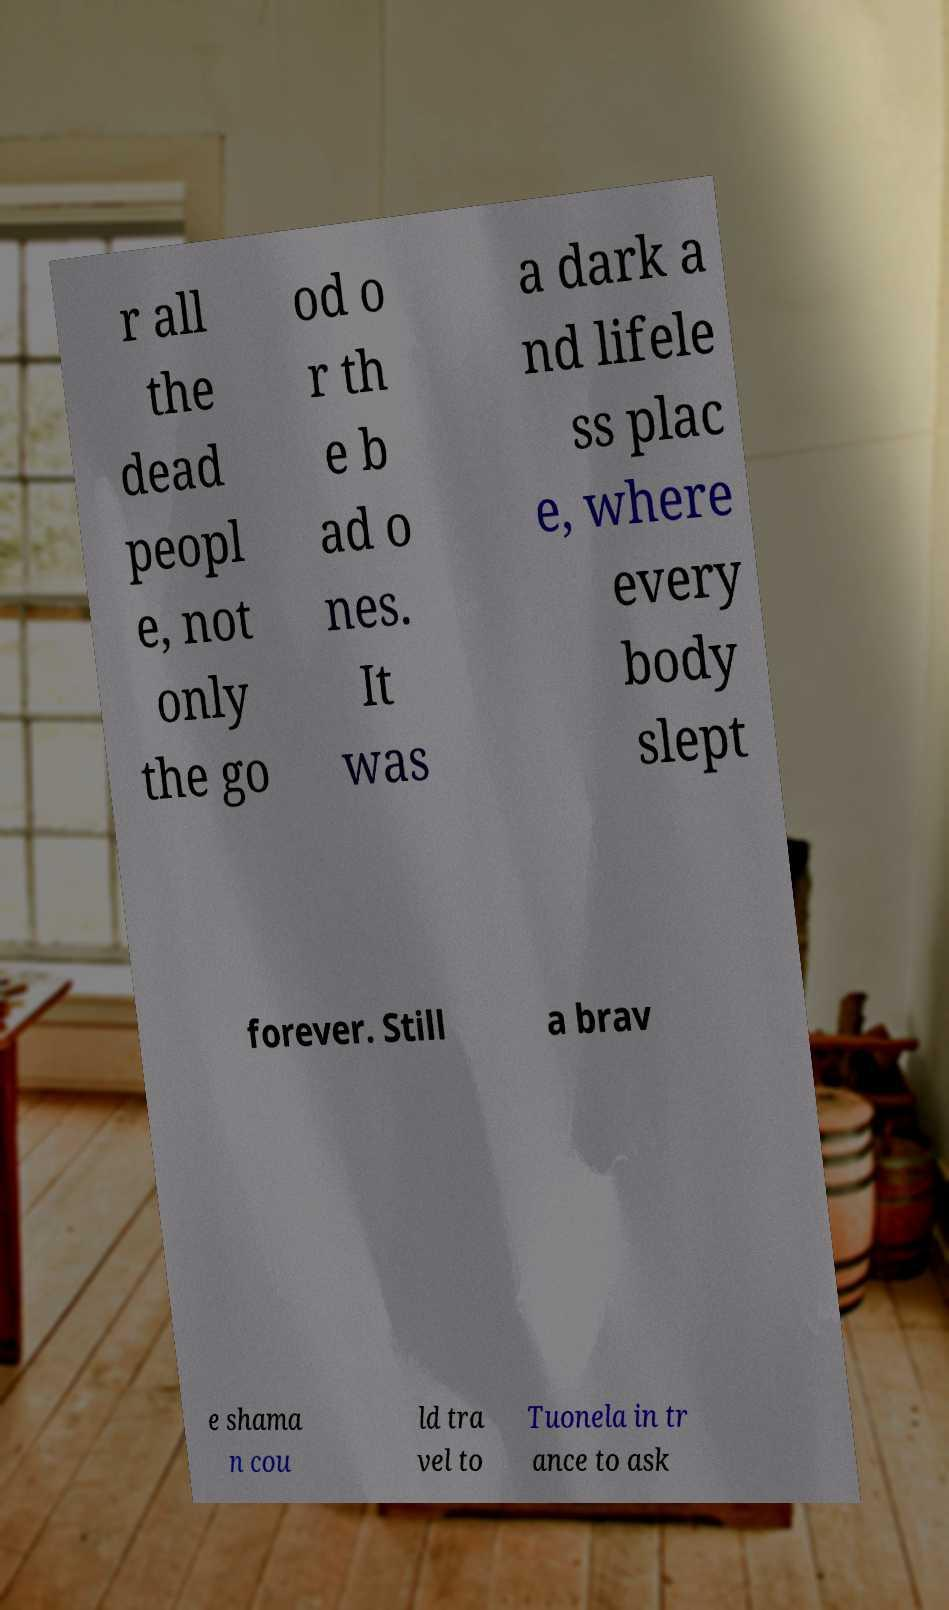Can you accurately transcribe the text from the provided image for me? r all the dead peopl e, not only the go od o r th e b ad o nes. It was a dark a nd lifele ss plac e, where every body slept forever. Still a brav e shama n cou ld tra vel to Tuonela in tr ance to ask 